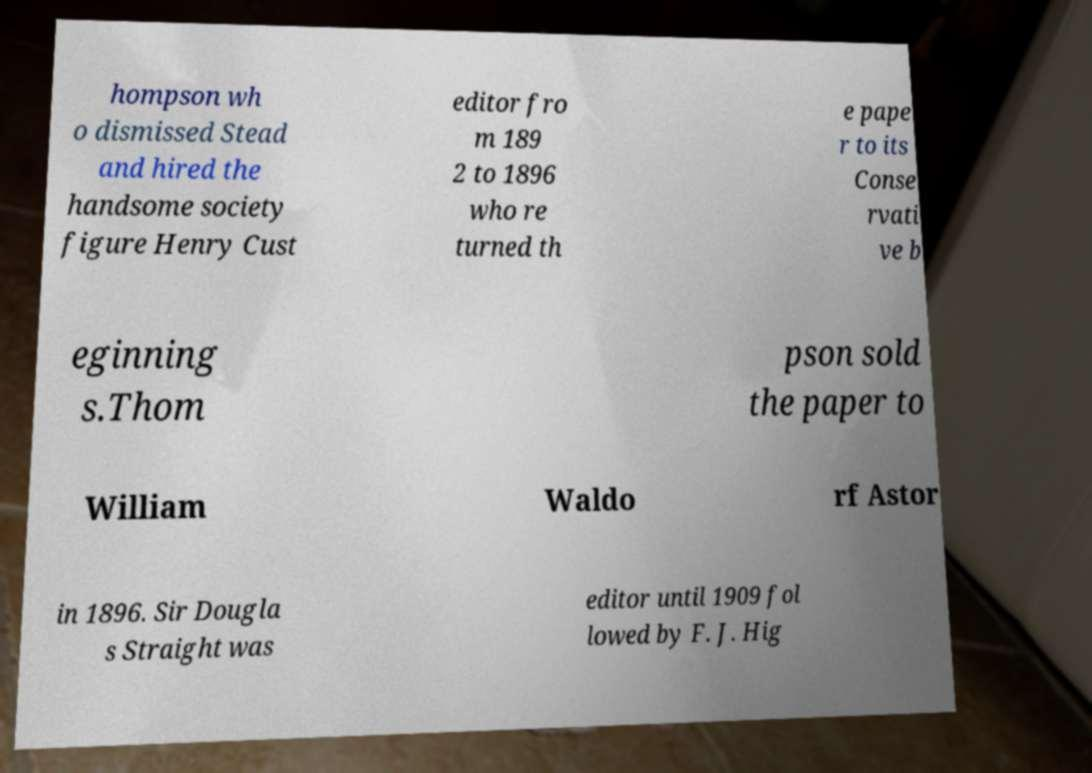For documentation purposes, I need the text within this image transcribed. Could you provide that? hompson wh o dismissed Stead and hired the handsome society figure Henry Cust editor fro m 189 2 to 1896 who re turned th e pape r to its Conse rvati ve b eginning s.Thom pson sold the paper to William Waldo rf Astor in 1896. Sir Dougla s Straight was editor until 1909 fol lowed by F. J. Hig 